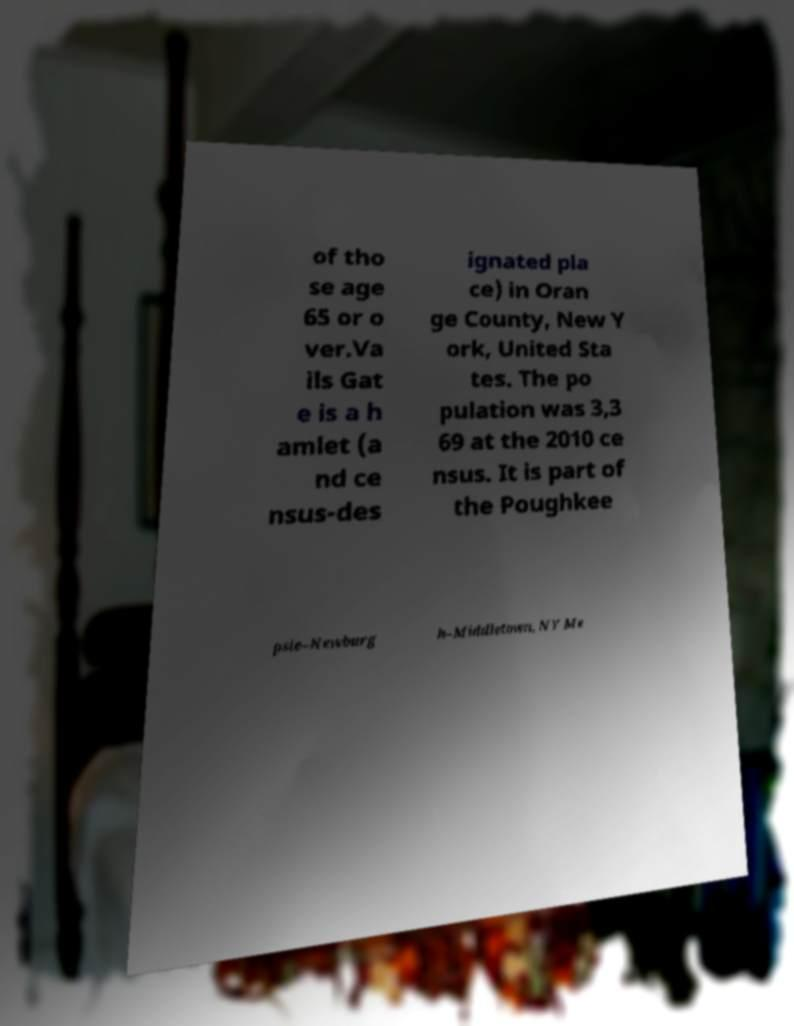Can you read and provide the text displayed in the image?This photo seems to have some interesting text. Can you extract and type it out for me? of tho se age 65 or o ver.Va ils Gat e is a h amlet (a nd ce nsus-des ignated pla ce) in Oran ge County, New Y ork, United Sta tes. The po pulation was 3,3 69 at the 2010 ce nsus. It is part of the Poughkee psie–Newburg h–Middletown, NY Me 